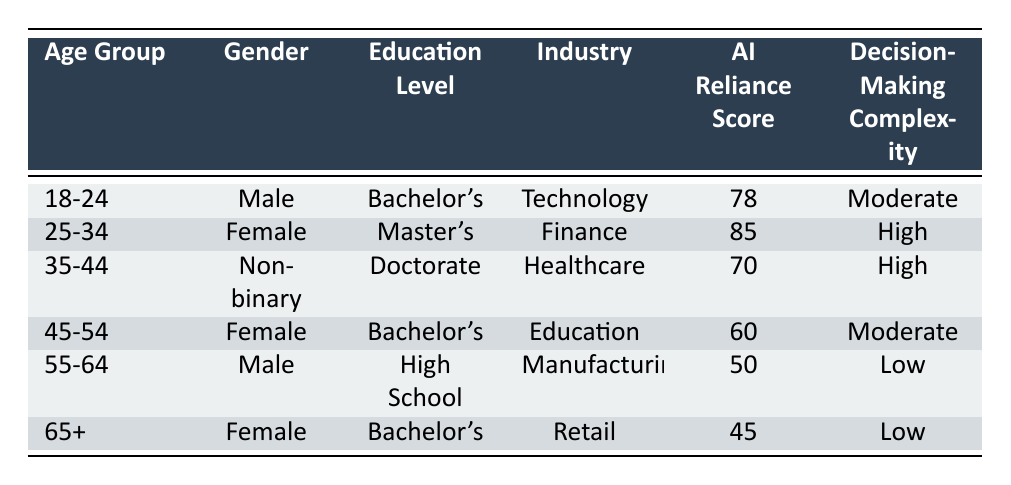What is the AI reliance score for the age group 25-34? Referring to the table, the AI reliance score for the age group 25-34 is found in the corresponding row, which shows a score of 85.
Answer: 85 Which industry has the highest AI reliance score? By scanning the AI reliance scores for each industry, the highest score is 85 associated with the Finance industry from the age group 25-34.
Answer: Finance What is the average AI reliance score among all age groups? To find the average, we first sum the AI reliance scores: 78 + 85 + 70 + 60 + 50 + 45 = 388. Since there are 6 age groups, the average score is 388 / 6 = 64.67.
Answer: 64.67 Are there more males or females represented in the table? The table shows 3 males (in the age groups 18-24 and 55-64) and 3 females (in the age groups 25-34, 45-54, and 65+). Therefore, there are equal numbers of males and females.
Answer: No Which education level corresponds to the lowest AI reliance score? Looking at the table, the lowest AI reliance score is 45, which corresponds to individuals with a Bachelor's degree in the age group 65+.
Answer: Bachelor's What is the difference in AI reliance scores between the highest (25-34) and the lowest (65+) age groups? The highest score is 85 (age group 25-34) and the lowest score is 45 (age group 65+). The difference is calculated as 85 - 45 = 40.
Answer: 40 Is there any age group with 'Low' decision-making complexity that has a score above 50? Examining the age groups marked as 'Low' decision-making complexity (55-64 and 65+), their scores are 50 and 45 respectively, both are below 50. Therefore, there are no age groups fitting this criteria.
Answer: No How many age groups have a 'High' decision-making complexity? The table indicates that two age groups, namely 25-34 and 35-44, are marked with 'High' decision-making complexity. Thus, there are 2 age groups.
Answer: 2 